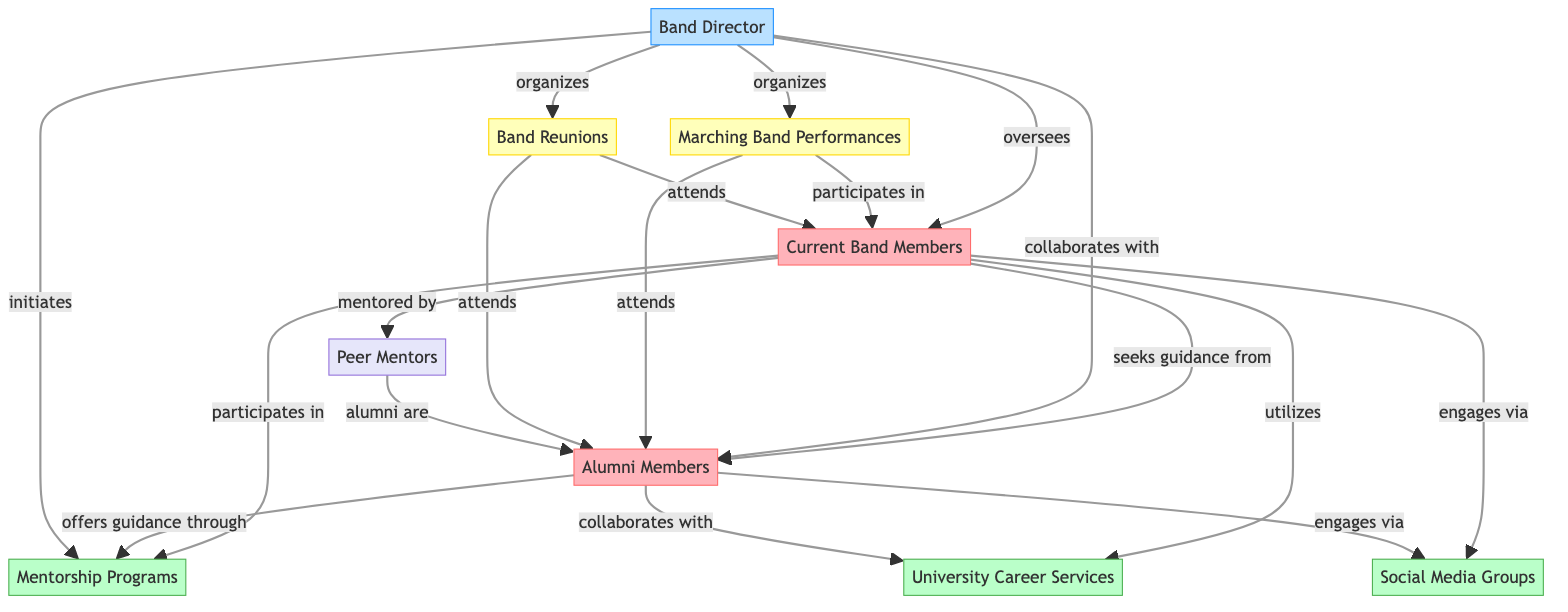What are the two main groups in this diagram? The diagram outlines two main groups: Current Band Members and Alumni Members. These are identified as "group" types in the nodes section, which indicates they represent larger categories within the network.
Answer: Current Band Members, Alumni Members How many resources are represented in the diagram? The diagram includes three resources: Mentorship Programs, University Career Services, and Social Media Groups. These are specified as resource types in the nodes section.
Answer: 3 What is the relationship between Current Band Members and Alumni Members? The relationship between Current Band Members and Alumni Members is defined by the label "seeks guidance from." This indicates a directional flow where current members look to alumni for advice and support, as shown by the edge connecting these two nodes.
Answer: seeks guidance from How many events are organized by the Band Director? The Band Director organizes two events: Marching Band Performances and Band Reunions. This can be seen in the edges from the Band Director node to both event nodes with the label "organizes."
Answer: 2 Who attends the Band Reunions? Both Current Band Members and Alumni Members attend the Band Reunions, as indicated by the edges from the Band Reunions node to each of these groups, showing their participation in this event.
Answer: Current Band Members, Alumni Members Which group utilizes University Career Services? The group that utilizes University Career Services is the Current Band Members, as shown by the directed edge labeled "utilizes" going from the Current Band Members node to the University Career Services node.
Answer: Current Band Members What role do Peer Mentors play in relation to Current Band Members and Alumni Members? Peer Mentors mentored Current Band Members and are categorized as representing the connection that alumni have with current students. The diagram indicates that Current Band Members are "mentored by" Peer Mentors and that "alumni are" Peer Mentors, depicting the two-way interaction between these groups.
Answer: mentored by What type of connection do both Current Band Members and Alumni Members have with Social Media Groups? Both groups "engage via" Social Media Groups, as illustrated by the directed edges connecting each group to the Social Media Groups node with that same label.
Answer: engage via How is the connection between the Band Director and Mentorship Programs characterized? The connection is characterized as "initiates." This is indicated by the directed edge from the Band Director to the Mentorship Programs node, signifying that the Band Director plays a key role in starting or creating these mentorship initiatives.
Answer: initiates 